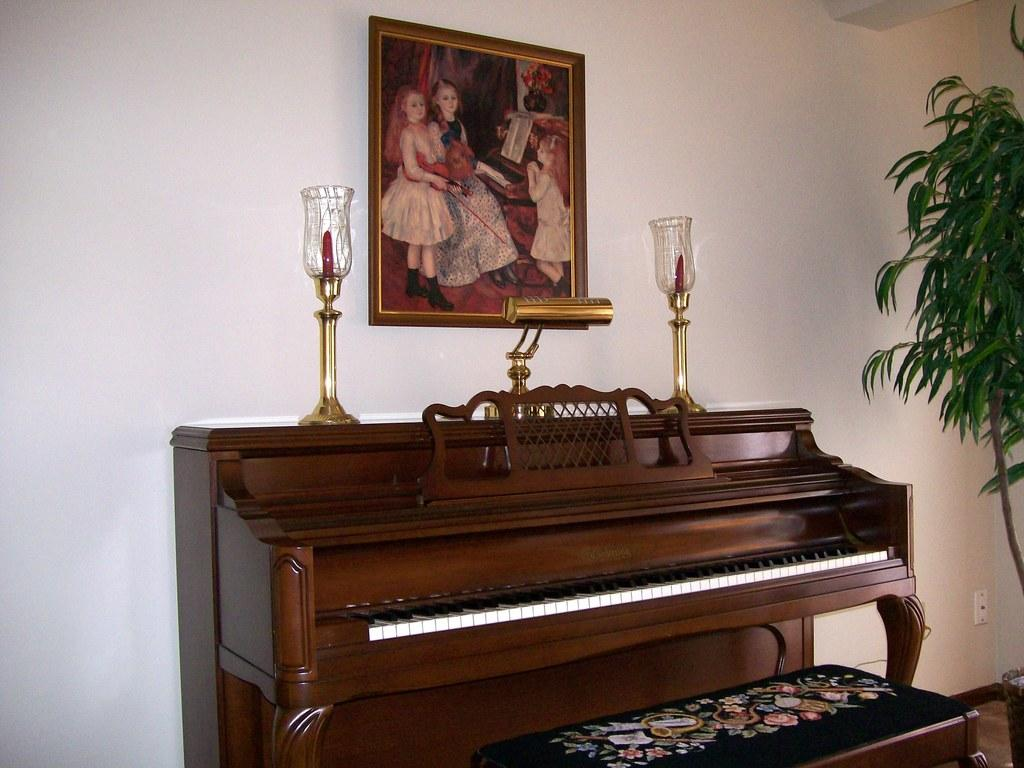What type of furniture is in the center of the image? There is a piano table in the image. What is placed in front of the piano table? There is a bench in front of the table. Where is the plant located in the image? The plant is in the right corner of the image. How many lamps are on the table? There are two lamps on the table. What can be seen on the wall in the image? There is a frame on the wall. What language is the piano playing in the image? The image does not show a piano playing, so it is not possible to determine the language of the music. 